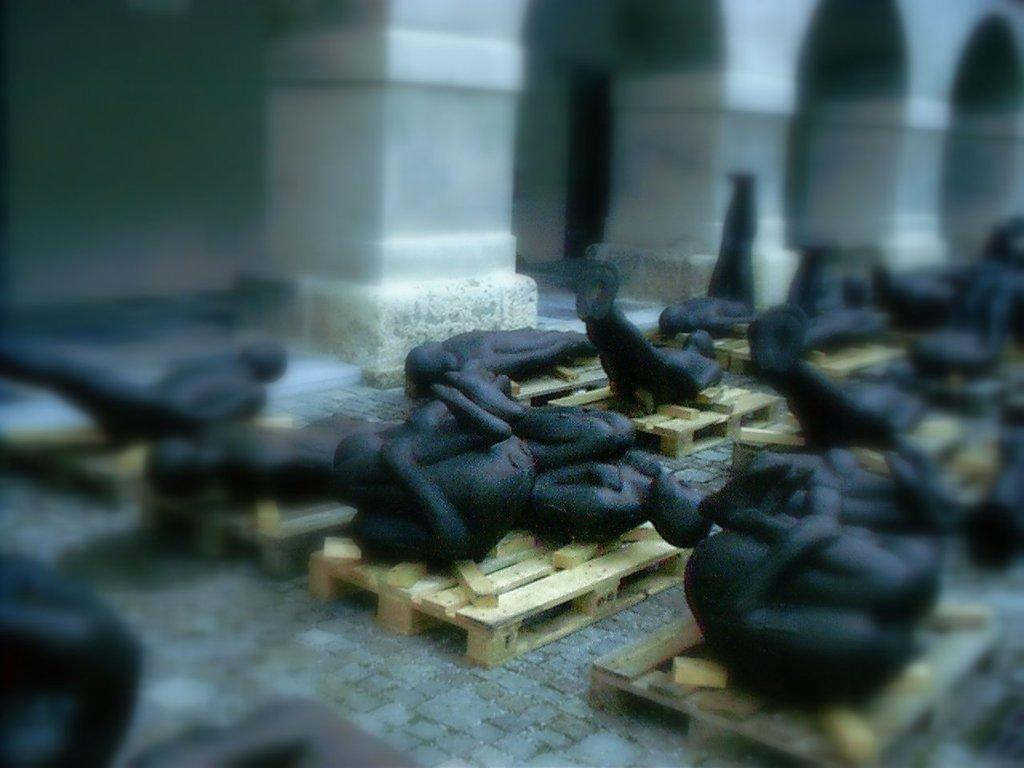What type of objects are depicted in the image? There are statues of human beings in the image. What are the statues placed on? The statues are on wooden things. What type of letters are being delivered by the statues in the image? There are no letters or any indication of delivery in the image; it only features statues of human beings on wooden things. 